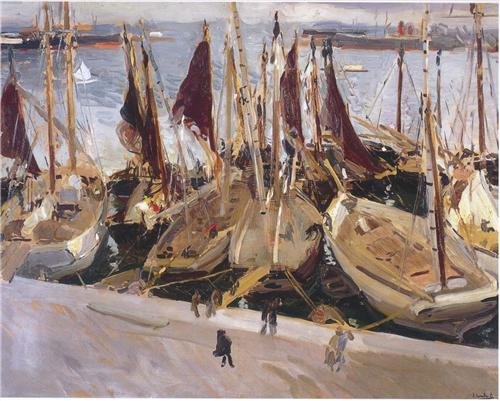Explain the visual content of the image in great detail. The image features an impressionist painting depicting a vibrant harbor scene. The foreground is dominated by numerous sailboats, closely moored together with their sails furled. The colors of the boats vary mainly in hues of white, beige, and red, creating a vivid contrast against the reflective waters. The painting’s style is characterized by loose and visible brushstrokes, which is a hallmark of the Impressionist movement, aiming to capture transient effects of light and color.

In the background, there's a distant city skyline rendered with soft, muted tones that suggest the time of day might be either early morning or late afternoon. This background is separated from the foreground by a serene body of water, its surface animated with ripples caused by the boats and possibly the bustling activity in the harbor.

Several human figures are scattered around the docks and on the boats, giving life and narrative to the scene. Their forms are more suggested than detailed, contributing to the overall dynamic and lively atmosphere of the piece. The overall composition evokes a snapshot of daily life in a bustling, thriving harbor, rich with movement and energy. 